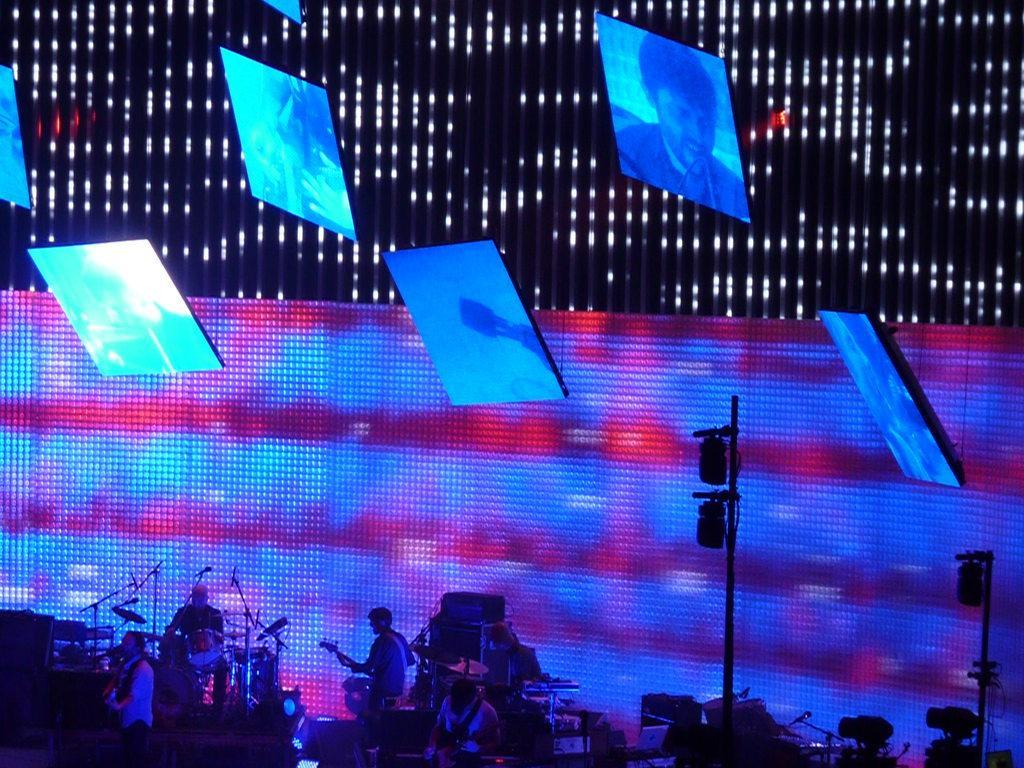Describe this image in one or two sentences. At the bottom of the image we can see musical instruments, some persons, lights, poles. In the background of the image we can see boards with lights, screens. 